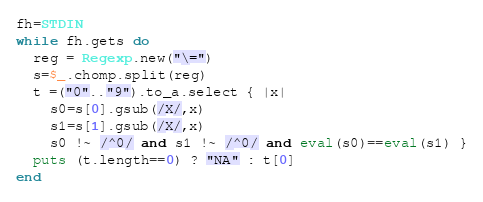<code> <loc_0><loc_0><loc_500><loc_500><_Ruby_>fh=STDIN
while fh.gets do
  reg = Regexp.new("\=")
  s=$_.chomp.split(reg)
  t =("0".."9").to_a.select { |x|
    s0=s[0].gsub(/X/,x)
    s1=s[1].gsub(/X/,x)
    s0 !~ /^0/ and s1 !~ /^0/ and eval(s0)==eval(s1) }
  puts (t.length==0) ? "NA" : t[0]
end</code> 